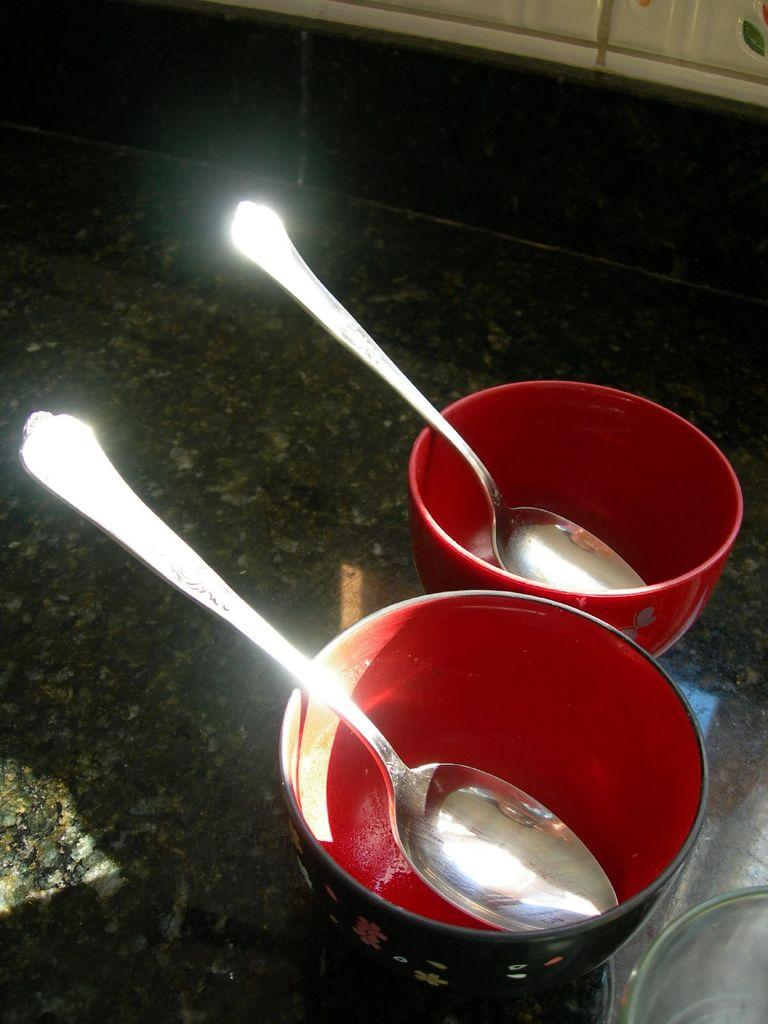What objects are present in the image? There are bowls and spoons in the image. Where are the bowls and spoons located? The bowls and spoons are on a counter. What might be used to eat the contents of the bowls? The spoons in the image can be used to eat the contents of the bowls. What color is the crayon used to draw on the bowls in the image? There is no crayon present in the image, and the bowls are not drawn on. 